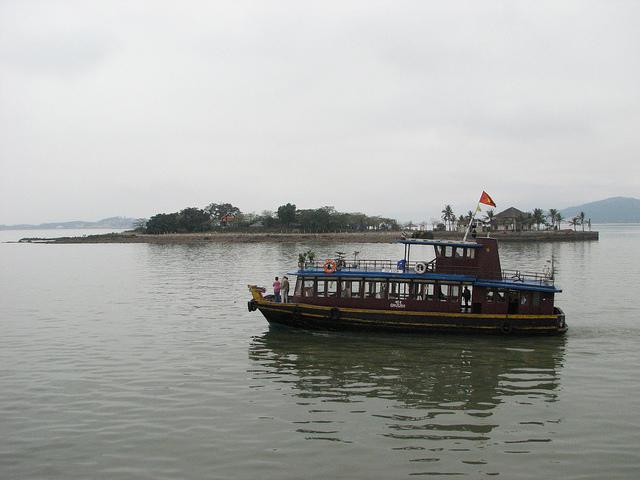Is the boat in good condition?
Quick response, please. Yes. What color are the clouds?
Keep it brief. Gray. Which boat is moving?
Concise answer only. Yes. Is the boat next to a pier?
Keep it brief. No. Is this boat near a port?
Concise answer only. No. What color is the water?
Quick response, please. Gray. What is in the background?
Keep it brief. Island. What surface would a vehicle that looks like this normally travel on?
Give a very brief answer. Water. Does this form of transportation look safe?
Concise answer only. Yes. How many life preservers are visible?
Give a very brief answer. 0. Are they whale watching?
Give a very brief answer. No. What are the colors on the boat?
Quick response, please. Blue. How many different kinds of flags are posted on the boat?
Give a very brief answer. 1. Is this a boat dock?
Give a very brief answer. No. Are there any homes on shore?
Answer briefly. Yes. Is it a sunny day?
Keep it brief. No. Is it a pretty day?
Write a very short answer. No. Do you see any humans on the boat?
Be succinct. Yes. What kind of boat is this?
Quick response, please. Ferry. 